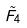<formula> <loc_0><loc_0><loc_500><loc_500>\tilde { F } _ { 4 }</formula> 